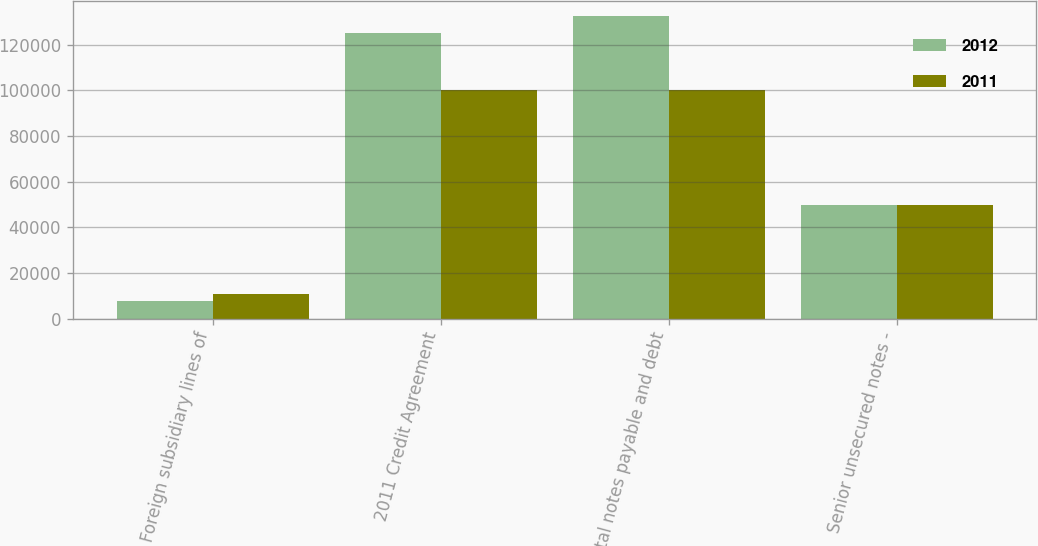Convert chart to OTSL. <chart><loc_0><loc_0><loc_500><loc_500><stacked_bar_chart><ecel><fcel>Foreign subsidiary lines of<fcel>2011 Credit Agreement<fcel>Total notes payable and debt<fcel>Senior unsecured notes -<nl><fcel>2012<fcel>7781<fcel>125000<fcel>132781<fcel>50000<nl><fcel>2011<fcel>10832<fcel>100000<fcel>100000<fcel>50000<nl></chart> 